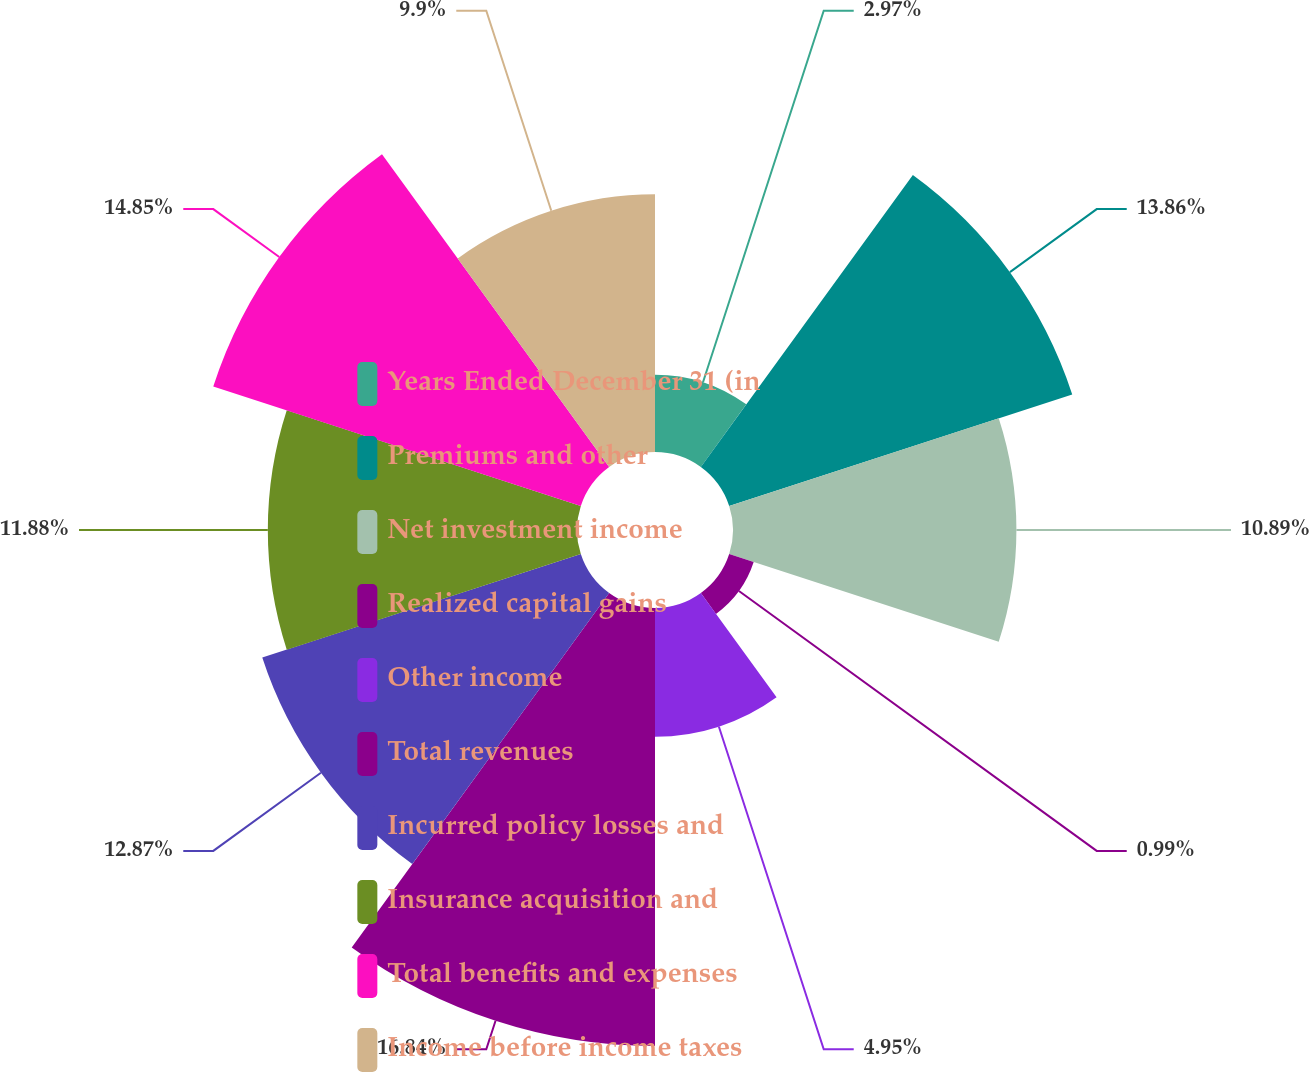Convert chart. <chart><loc_0><loc_0><loc_500><loc_500><pie_chart><fcel>Years Ended December 31 (in<fcel>Premiums and other<fcel>Net investment income<fcel>Realized capital gains<fcel>Other income<fcel>Total revenues<fcel>Incurred policy losses and<fcel>Insurance acquisition and<fcel>Total benefits and expenses<fcel>Income before income taxes<nl><fcel>2.97%<fcel>13.86%<fcel>10.89%<fcel>0.99%<fcel>4.95%<fcel>16.83%<fcel>12.87%<fcel>11.88%<fcel>14.85%<fcel>9.9%<nl></chart> 